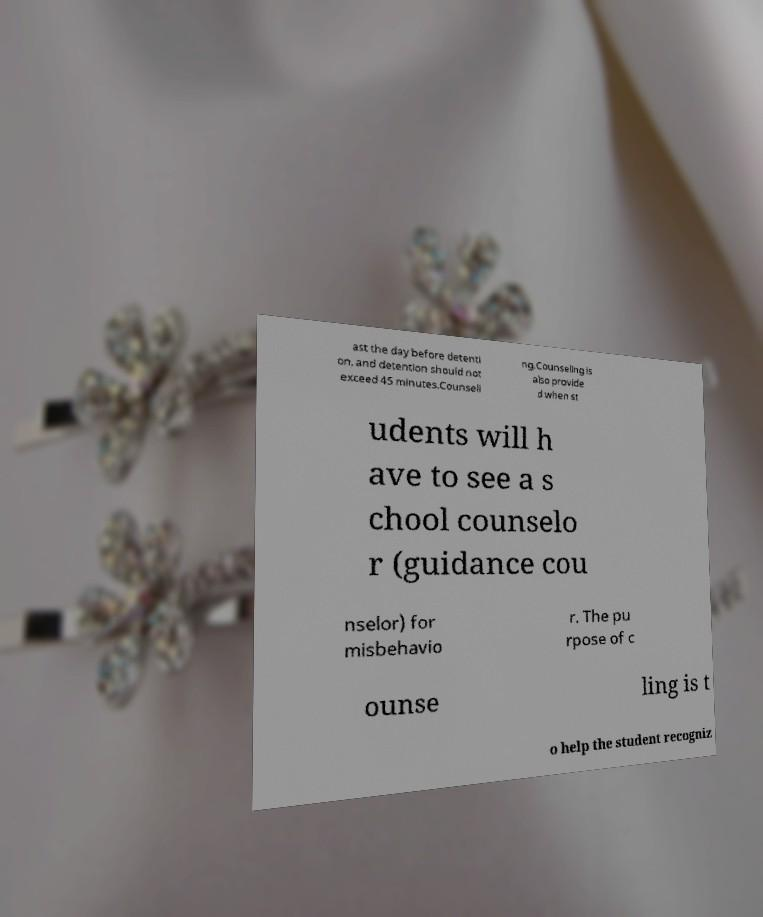Could you extract and type out the text from this image? ast the day before detenti on, and detention should not exceed 45 minutes.Counseli ng.Counseling is also provide d when st udents will h ave to see a s chool counselo r (guidance cou nselor) for misbehavio r. The pu rpose of c ounse ling is t o help the student recogniz 